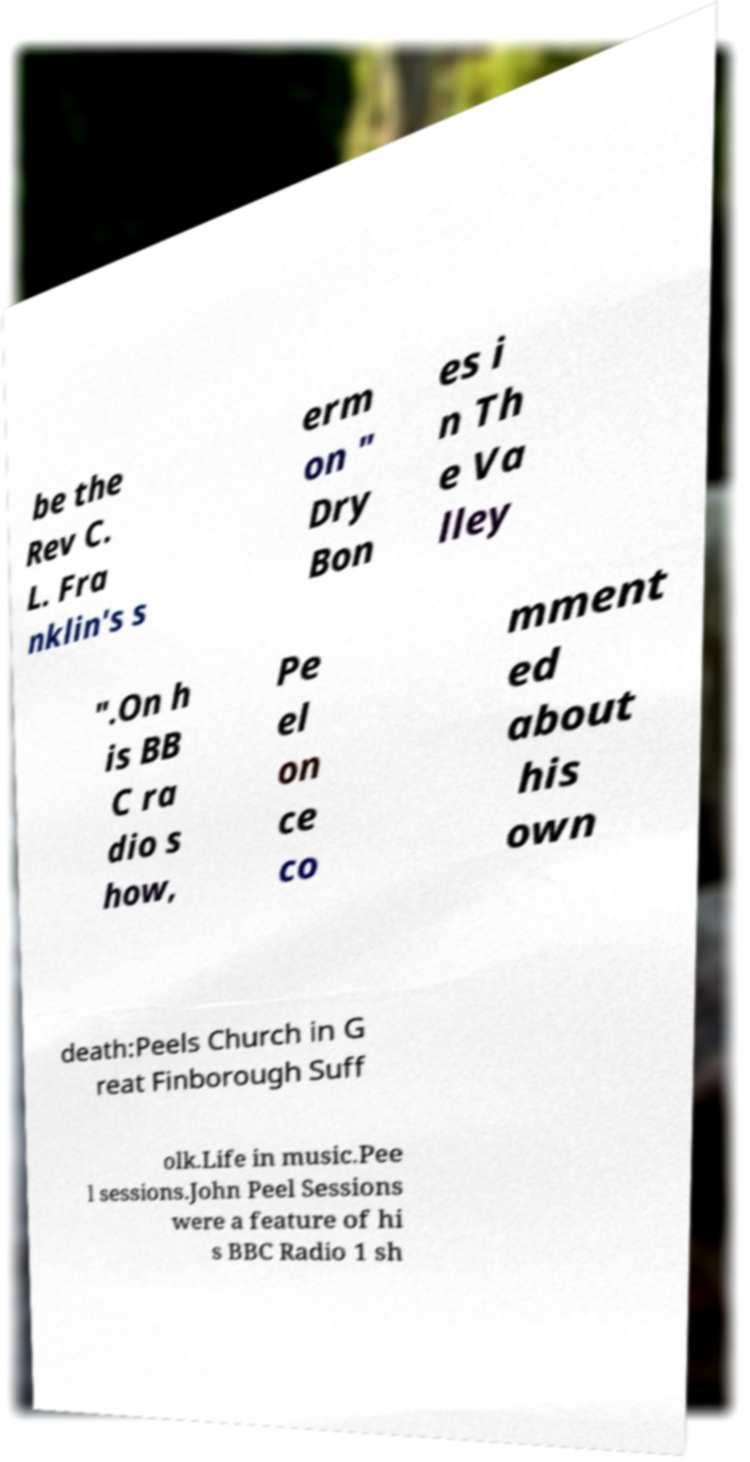What messages or text are displayed in this image? I need them in a readable, typed format. be the Rev C. L. Fra nklin's s erm on " Dry Bon es i n Th e Va lley ".On h is BB C ra dio s how, Pe el on ce co mment ed about his own death:Peels Church in G reat Finborough Suff olk.Life in music.Pee l sessions.John Peel Sessions were a feature of hi s BBC Radio 1 sh 